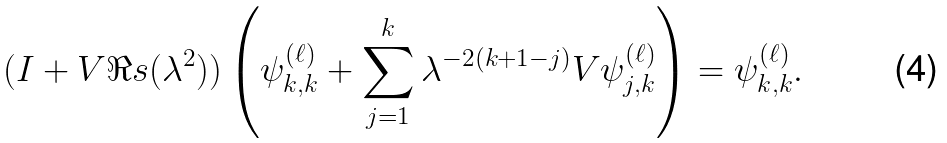Convert formula to latex. <formula><loc_0><loc_0><loc_500><loc_500>( I + V \Re s ( \lambda ^ { 2 } ) ) \left ( \psi _ { k , k } ^ { ( \ell ) } + \sum _ { j = 1 } ^ { k } \lambda ^ { - 2 ( k + 1 - j ) } V \psi _ { j , k } ^ { ( \ell ) } \right ) = \psi _ { k , k } ^ { ( \ell ) } .</formula> 